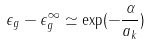Convert formula to latex. <formula><loc_0><loc_0><loc_500><loc_500>\epsilon _ { g } - \epsilon _ { g } ^ { \infty } \simeq \exp ( - \frac { \alpha } { a _ { k } } )</formula> 